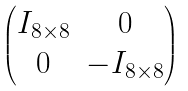<formula> <loc_0><loc_0><loc_500><loc_500>\begin{pmatrix} I _ { 8 \times 8 } & 0 \\ 0 & - I _ { 8 \times 8 } \end{pmatrix}</formula> 